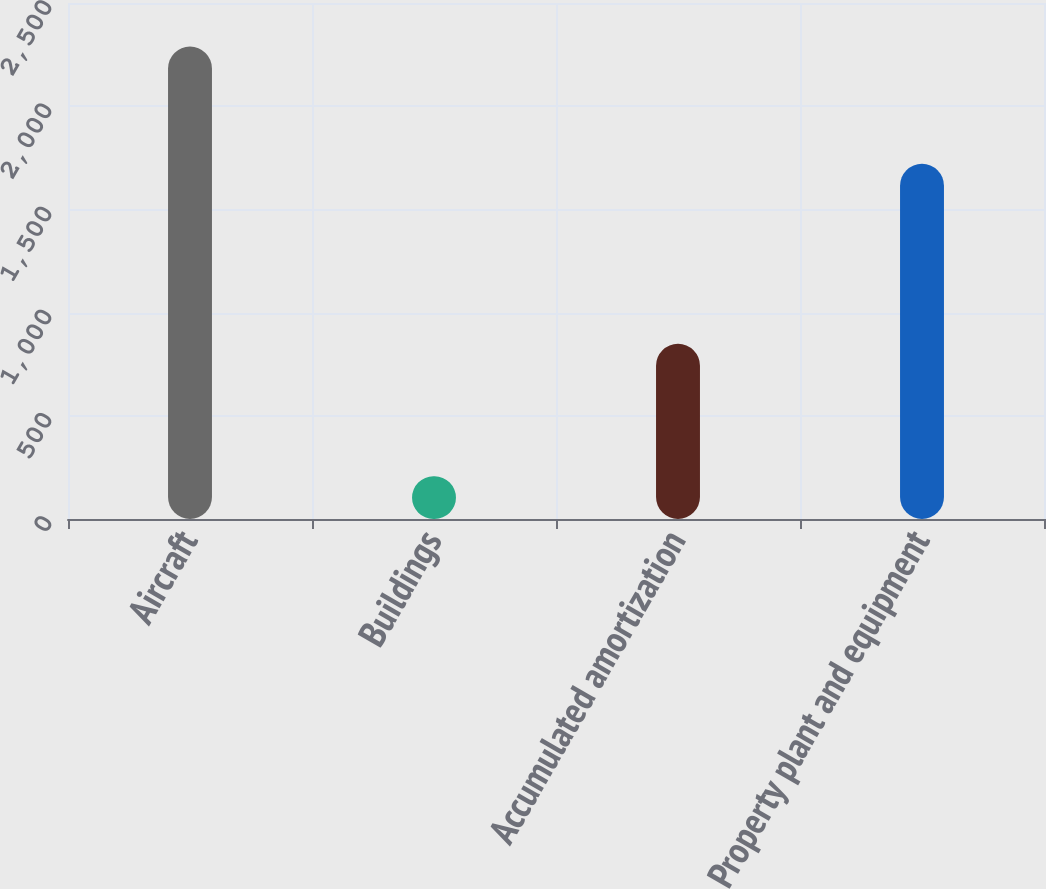Convert chart to OTSL. <chart><loc_0><loc_0><loc_500><loc_500><bar_chart><fcel>Aircraft<fcel>Buildings<fcel>Accumulated amortization<fcel>Property plant and equipment<nl><fcel>2289<fcel>207<fcel>849<fcel>1721<nl></chart> 